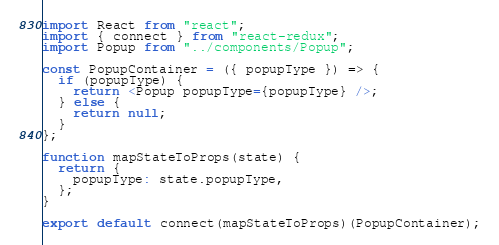<code> <loc_0><loc_0><loc_500><loc_500><_JavaScript_>import React from "react";
import { connect } from "react-redux";
import Popup from "../components/Popup";

const PopupContainer = ({ popupType }) => {
  if (popupType) {
    return <Popup popupType={popupType} />;
  } else {
    return null;
  }
};

function mapStateToProps(state) {
  return {
    popupType: state.popupType,
  };
}

export default connect(mapStateToProps)(PopupContainer);
</code> 